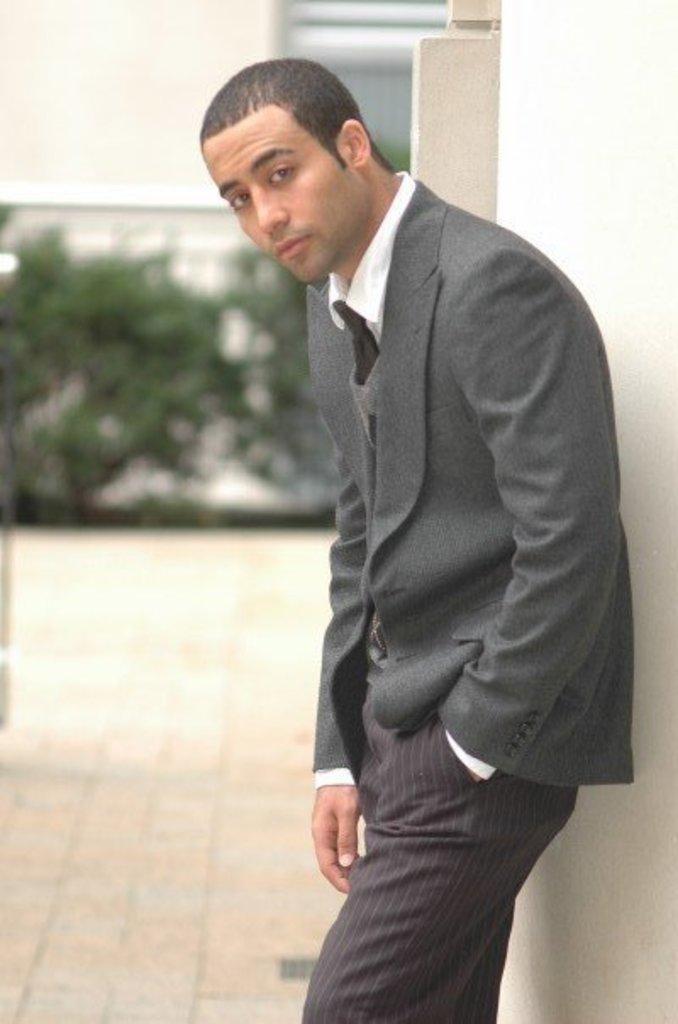What is the main subject of the image? There is a man standing in the image. What is the man wearing? The man is wearing a suit. What can be seen in the background of the image? There are plants and a wall in the background of the image. What type of wound can be seen on the leaf in the image? There is no leaf or wound present in the image. How many apples are visible on the wall in the image? There are no apples present in the image; only plants and a wall can be seen in the background. 